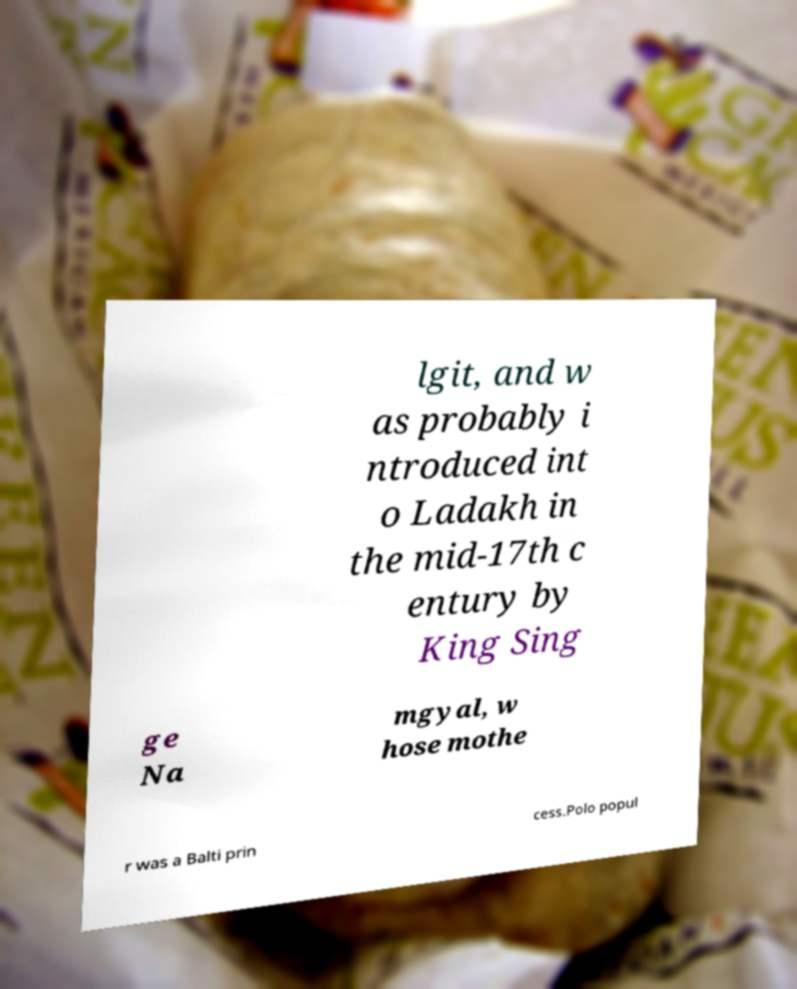Could you extract and type out the text from this image? lgit, and w as probably i ntroduced int o Ladakh in the mid-17th c entury by King Sing ge Na mgyal, w hose mothe r was a Balti prin cess.Polo popul 